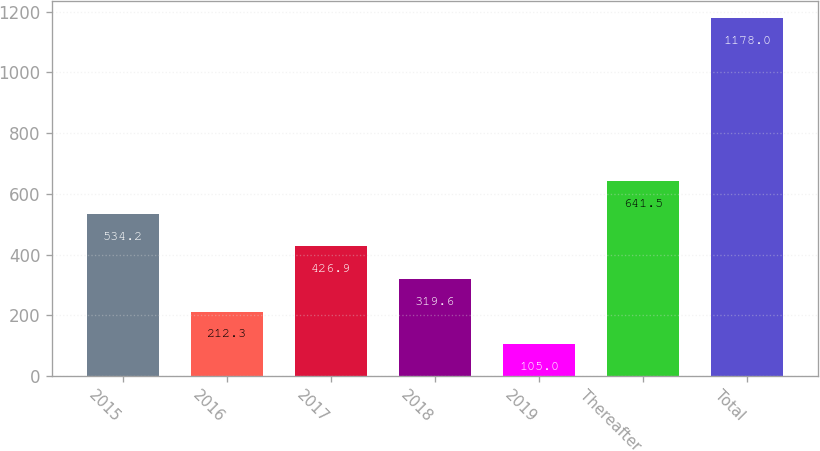<chart> <loc_0><loc_0><loc_500><loc_500><bar_chart><fcel>2015<fcel>2016<fcel>2017<fcel>2018<fcel>2019<fcel>Thereafter<fcel>Total<nl><fcel>534.2<fcel>212.3<fcel>426.9<fcel>319.6<fcel>105<fcel>641.5<fcel>1178<nl></chart> 